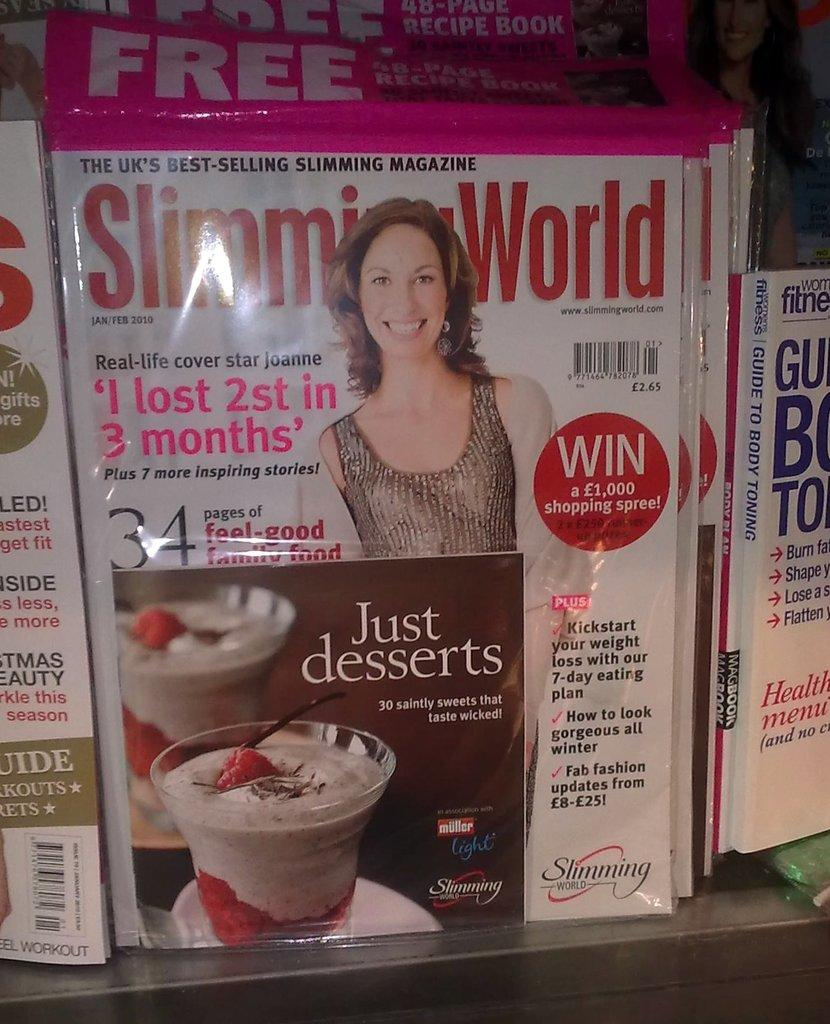Provide a one-sentence caption for the provided image. With this magazine you can win a £1000 shopping spree. 